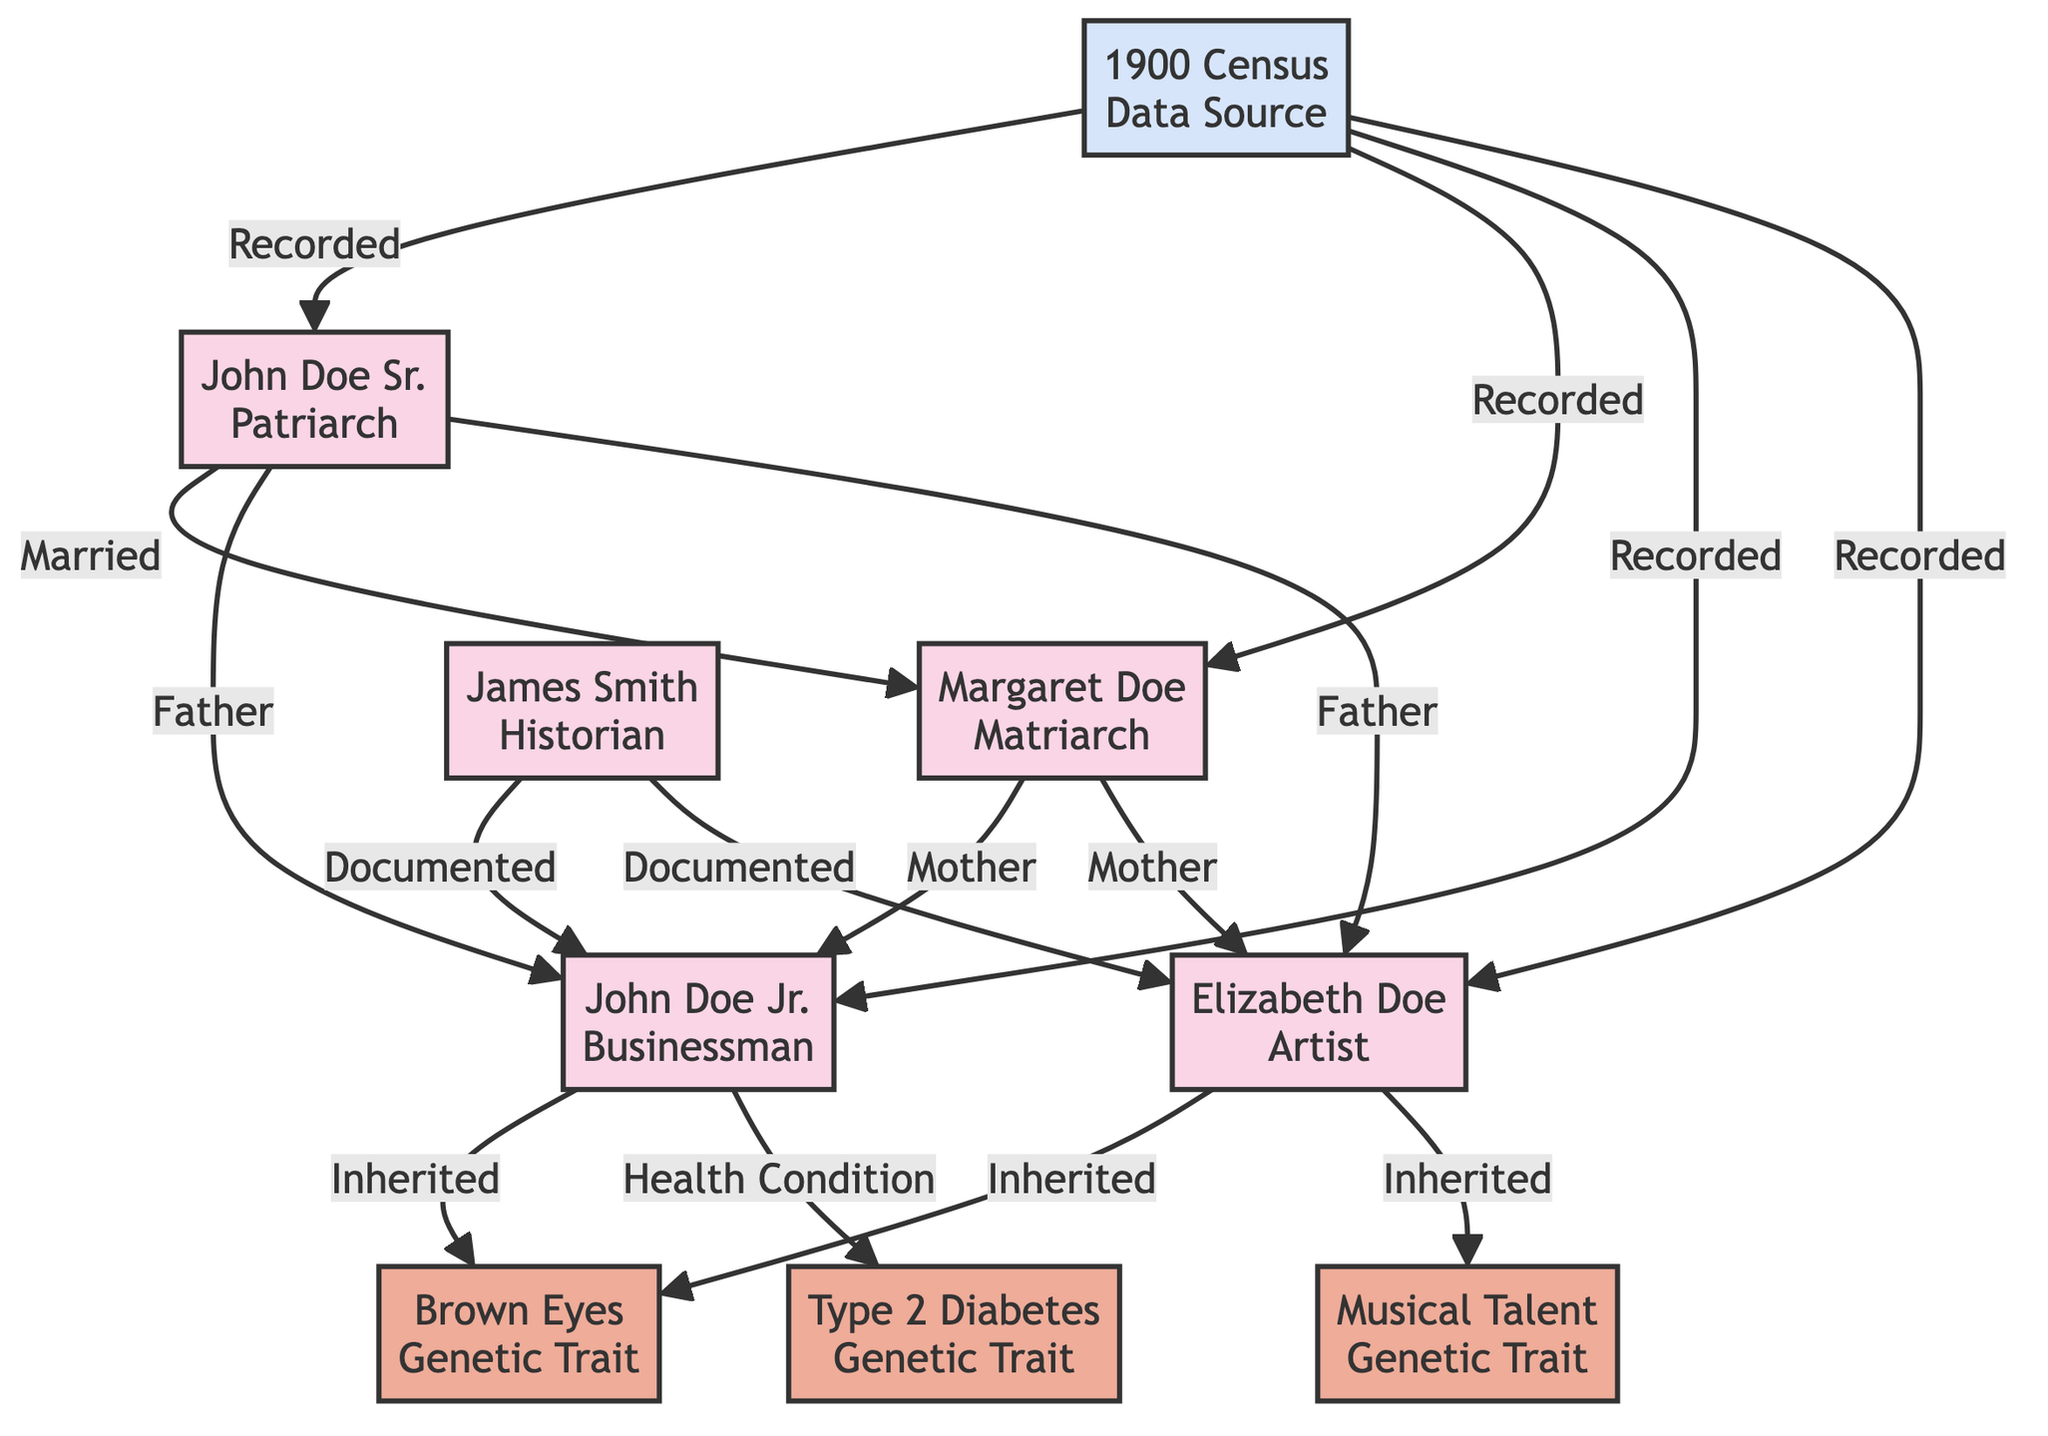What are the names of the patriarch and matriarch of the Doe family? The diagram identifies John Doe Sr. as the patriarch and Margaret Doe as the matriarch. Both names are explicitly stated in their respective nodes in the diagram.
Answer: John Doe Sr., Margaret Doe How many children did John Doe Sr. and Margaret Doe have? The diagram shows that John Doe Sr. and Margaret Doe have two children: John Doe Jr. and Elizabeth Doe. This is evident from the arrows indicating the parental relationships leading to these two nodes.
Answer: 2 What genetic trait is inherited by both John Doe Jr. and Elizabeth Doe? The diagram indicates that both John Doe Jr. and Elizabeth Doe have inherited the "Brown Eyes" genetic trait, as shown by the arrows pointing from them to the "Brown Eyes" trait node.
Answer: Brown Eyes Which individual documented John Doe Jr. and Elizabeth Doe? The diagram shows that James Smith, labeled as a historian, documented both John Doe Jr. and Elizabeth Doe, with arrows indicating this relationship leading from his node to theirs.
Answer: James Smith What health condition is associated with John Doe Jr.? The diagram states that John Doe Jr. has a health condition of "Type 2 Diabetes," as illustrated by the arrow leading from John Doe Jr. to the Type 2 Diabetes node.
Answer: Type 2 Diabetes Which data source recorded information about the Doe family? The "1900 Census" node is identified as the data source that recorded details regarding John Doe Sr., Margaret Doe, John Doe Jr., and Elizabeth Doe, with arrows illustrating this linkage.
Answer: 1900 Census How many total genetic traits are shown in the diagram? The diagram lists three distinct genetic traits: "Brown Eyes," "Musical Talent," and "Type 2 Diabetes." The total is counted by identifying each trait node displayed in the diagram.
Answer: 3 What relationship does Margaret Doe have with John Doe Jr.? The diagram illustrates that Margaret Doe is the mother of John Doe Jr., as indicated by the "Mother" label and the connecting arrow pointing from Margaret to John Doe Jr.
Answer: Mother What type of talent did Elizabeth Doe inherit? According to the diagram, Elizabeth Doe inherited the "Musical Talent" genetic trait, as indicated by the arrow pointing from her node to the "Musical Talent" trait node.
Answer: Musical Talent 